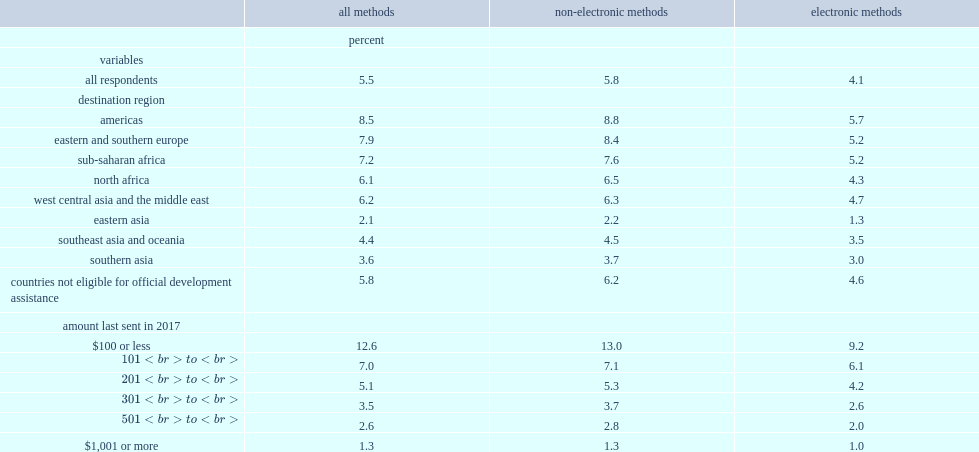Which methods are sending fees lower for, emt methods or non-emt methods? Electronic methods. What is the percentage of sending fees for emts? 4.1. What is the percentage of sending fees for non-emt methods? 5.8. What is the percentage of the fees for sending remittances to eastern asia for funds sent via emt methods? 1.3. What is the percentage of the fees for sending remittances to eastern asia for funds sent via non-emt methods? 2.2. What is the percentage of the average fees for funds sent via emt methods for remittances sent to the americas? 5.7. What is the percentage of the average fees for funds sent via non-emt methods for remittances sent to the americas? 8.8. 